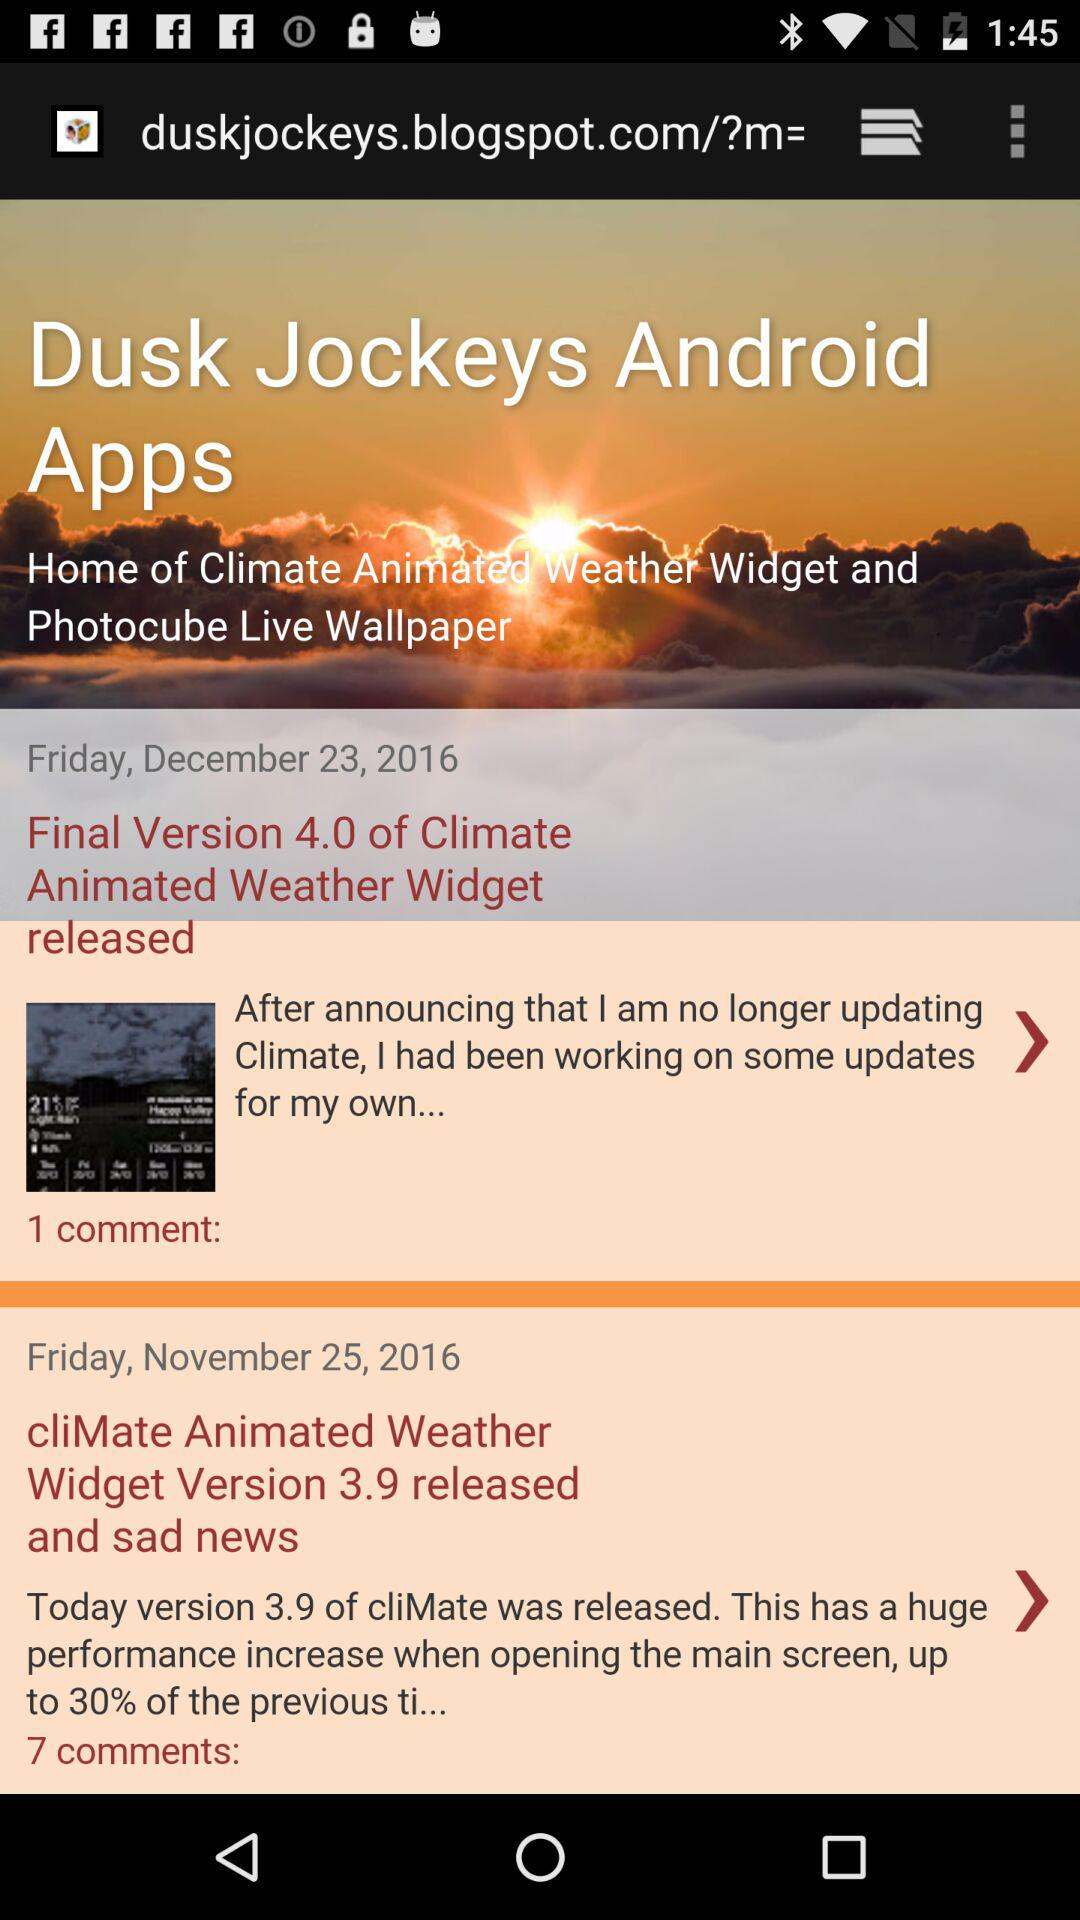How many comments are there in total on both posts?
Answer the question using a single word or phrase. 8 